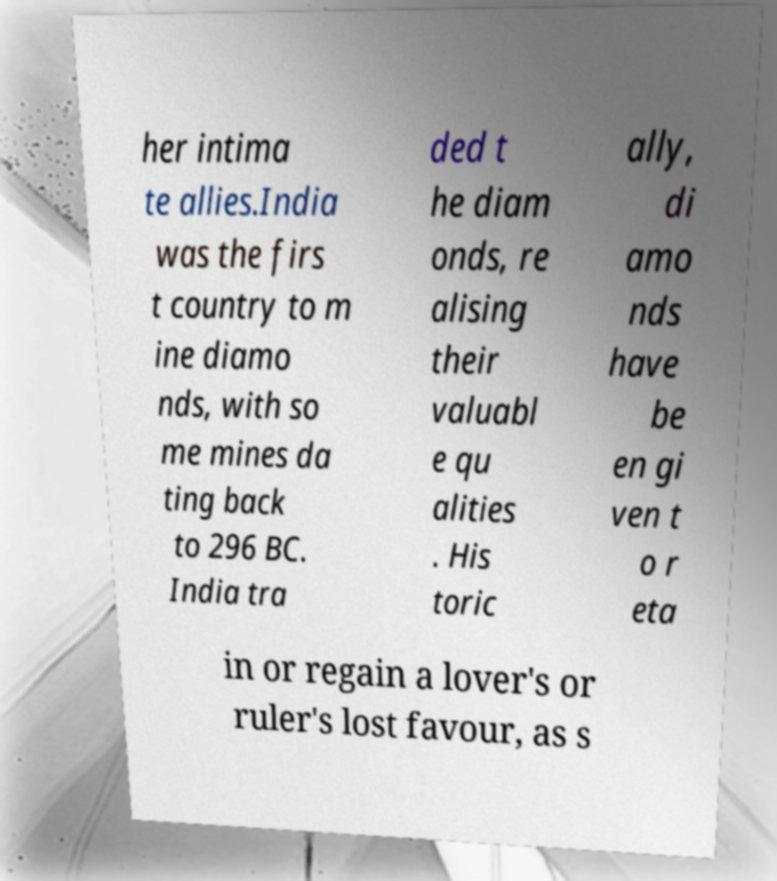I need the written content from this picture converted into text. Can you do that? her intima te allies.India was the firs t country to m ine diamo nds, with so me mines da ting back to 296 BC. India tra ded t he diam onds, re alising their valuabl e qu alities . His toric ally, di amo nds have be en gi ven t o r eta in or regain a lover's or ruler's lost favour, as s 